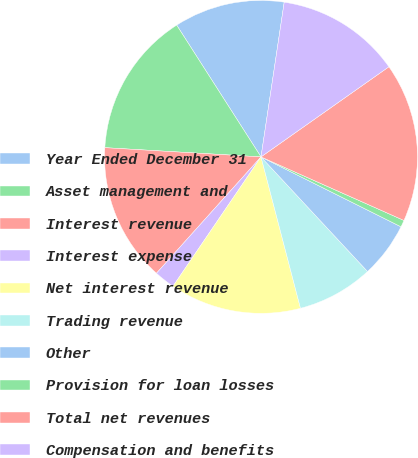Convert chart. <chart><loc_0><loc_0><loc_500><loc_500><pie_chart><fcel>Year Ended December 31<fcel>Asset management and<fcel>Interest revenue<fcel>Interest expense<fcel>Net interest revenue<fcel>Trading revenue<fcel>Other<fcel>Provision for loan losses<fcel>Total net revenues<fcel>Compensation and benefits<nl><fcel>11.43%<fcel>15.0%<fcel>14.29%<fcel>2.14%<fcel>13.57%<fcel>7.86%<fcel>5.71%<fcel>0.71%<fcel>16.43%<fcel>12.86%<nl></chart> 